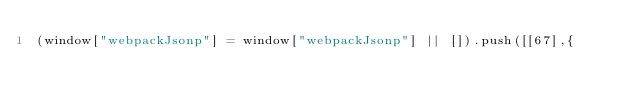<code> <loc_0><loc_0><loc_500><loc_500><_JavaScript_>(window["webpackJsonp"] = window["webpackJsonp"] || []).push([[67],{
</code> 